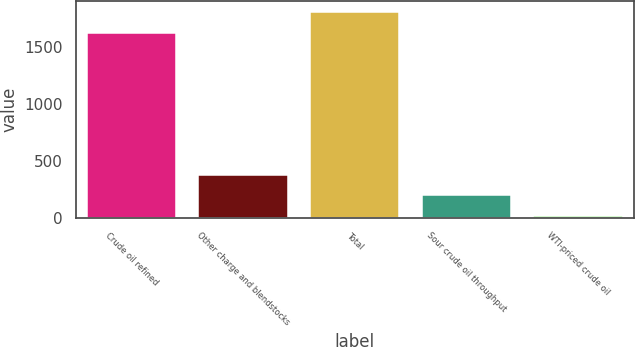Convert chart. <chart><loc_0><loc_0><loc_500><loc_500><bar_chart><fcel>Crude oil refined<fcel>Other charge and blendstocks<fcel>Total<fcel>Sour crude oil throughput<fcel>WTI-priced crude oil<nl><fcel>1622<fcel>376.4<fcel>1806<fcel>197.7<fcel>19<nl></chart> 